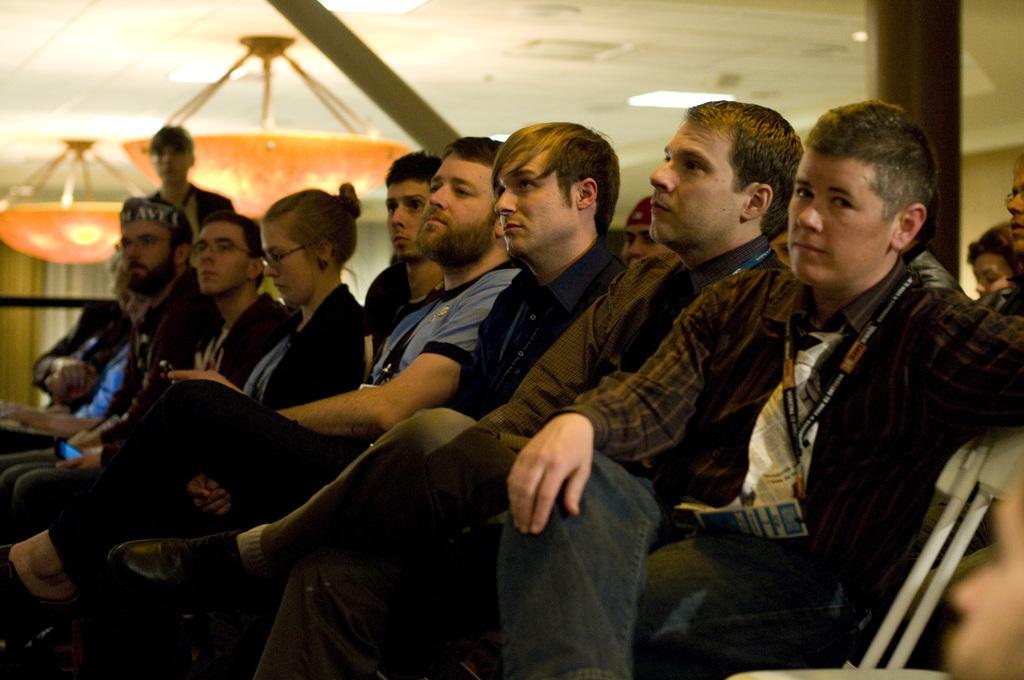Can you describe this image briefly? In the image there are few people sitting in a row and behind them there is a person standing. In the background there are some objects attached to the roof. 